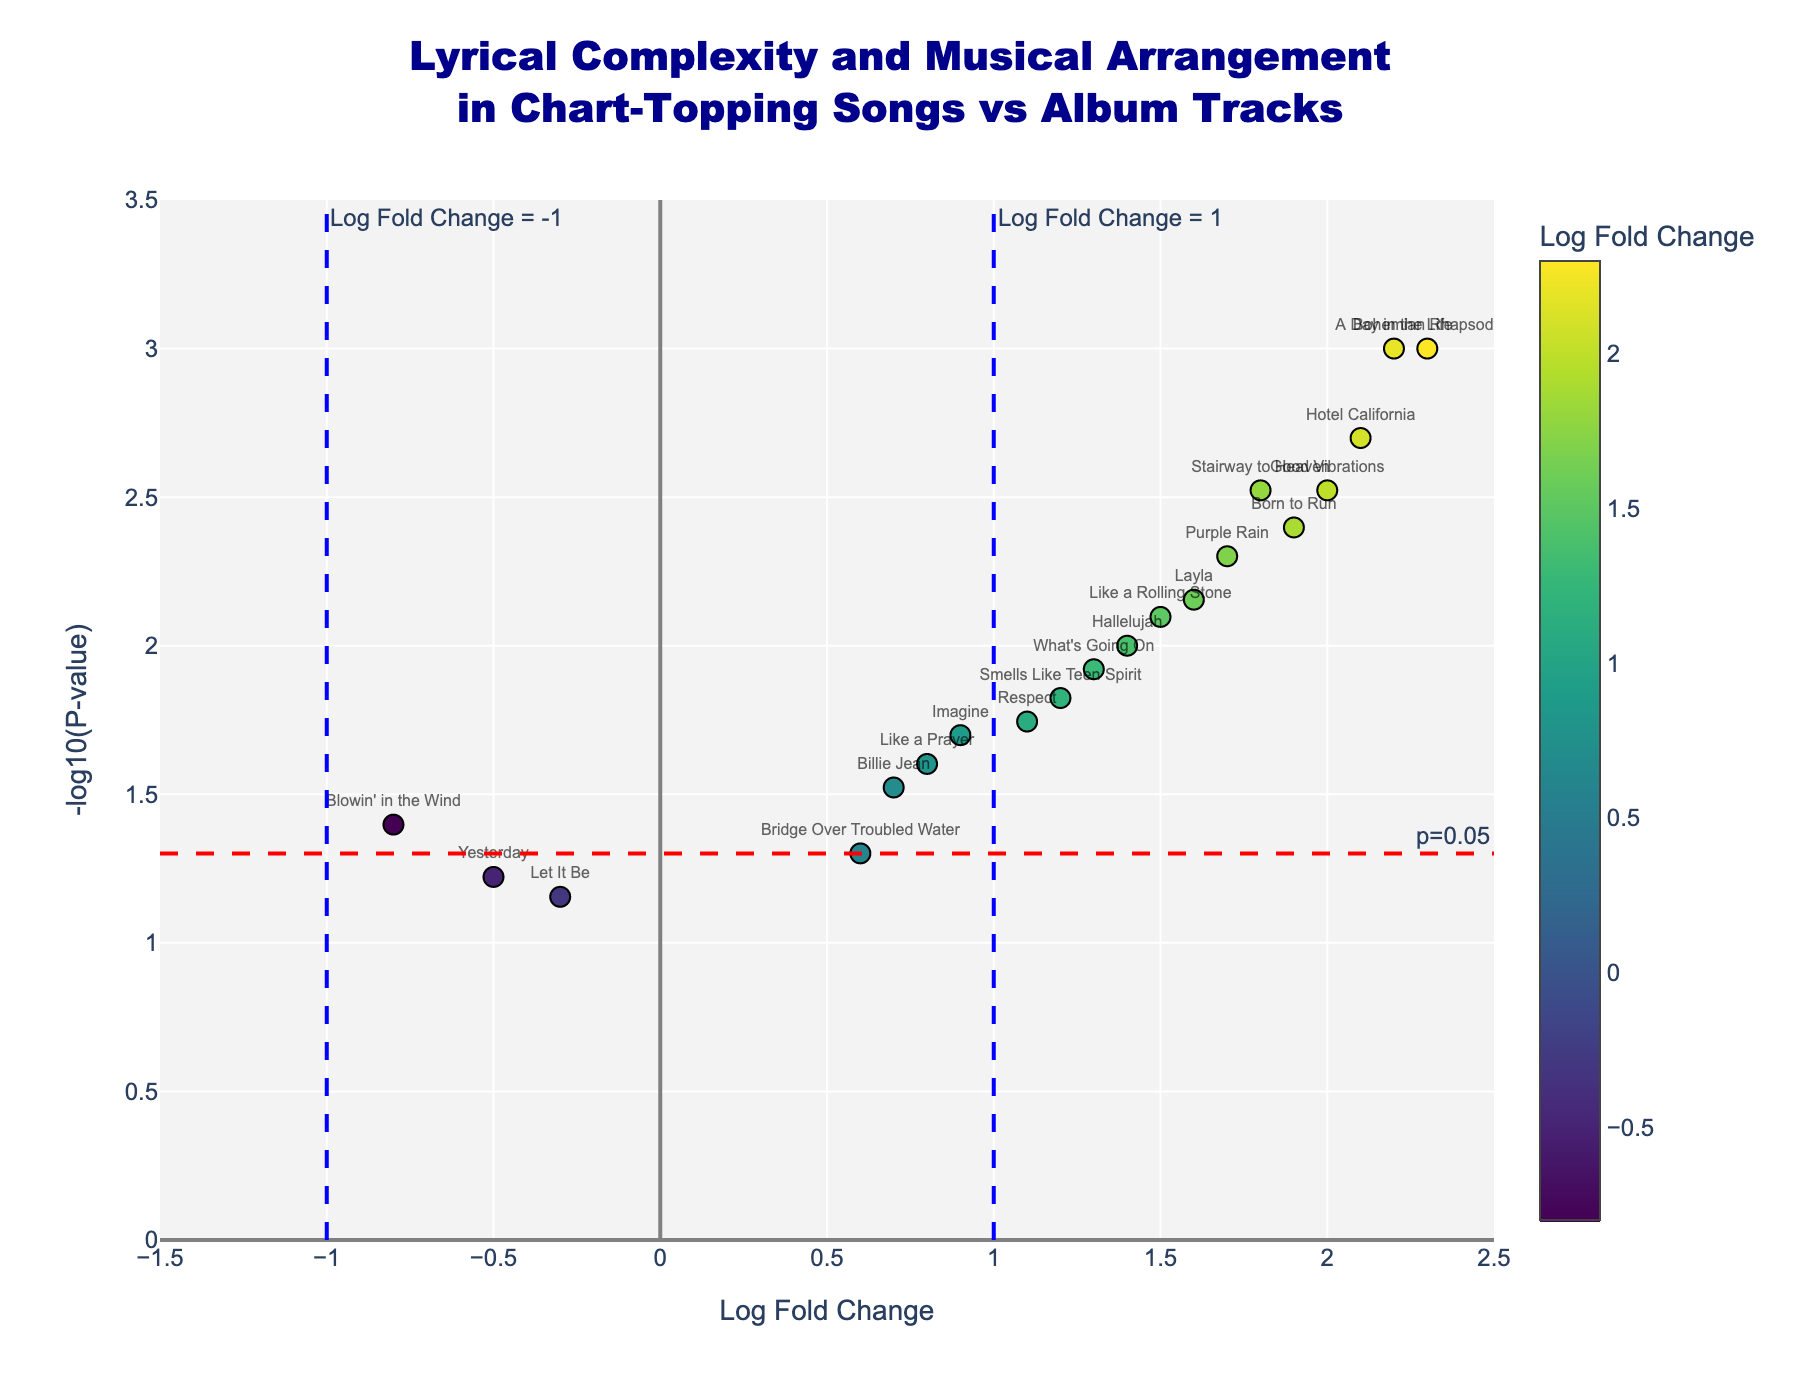What's the title of the plot? The title is usually displayed at the top of the plot, indicating what the plot represents. It helps viewers understand the overall context of the data.
Answer: "Lyrical Complexity and Musical Arrangement in Chart-Topping Songs vs Album Tracks" How many songs have a Log Fold Change greater than 1? To answer this, count the number of points where the x-axis (Log Fold Change) value is greater than 1. These points typically fall to the right of the vertical line at x=1.
Answer: 11 Which song has the highest Log Fold Change and what is its value? The song with the highest Log Fold Change will have the rightmost point on the x-axis. Identify this point and check the labeled text.
Answer: "Bohemian Rhapsody" with a Log Fold Change of 2.3 What is the significance threshold for P-value used in the plot? The significance threshold is marked by a horizontal dashed line and an annotation text. It typically indicates a conventional cut-off for statistical significance.
Answer: 0.05 How many songs have a P-value less than 0.01? Points below the horizontal line at y = -log10(0.01) represent songs with a P-value < 0.01. Count these points.
Answer: 6 Which songs fall below the significance threshold (P-value = 0.05)? Identify points below the horizontal dashed line at y = -log10(0.05). The songs labeled near these points fall below the threshold.
Answer: "Blowin' in the Wind", "Yesterday", "Let It Be", and "Bridge Over Troubled Water" Compare "Hotel California" and "Layla" in terms of Log Fold Change and P-value. Which one is more significant? Compare their Log Fold Change values and their P-values. Significance is better represented by lower P-value (higher -log10(P-value)).
Answer: "Hotel California" is more significant with a P-value of 0.002 compared to "Layla" with a P-value of 0.007 What is the Log Fold Change value at the median of all songs plotted? Order all Log Fold Change values and find the middle value. For simplicity, consider the sorted Log Fold Change values and pick the middle if odd number or average the two middle values if even number.
Answer: 1.4 